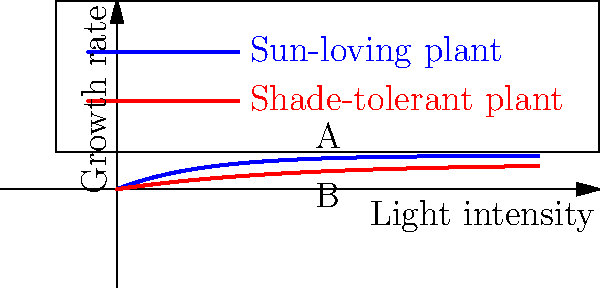Compare the growth patterns of sun-loving and shade-tolerant plants represented by curves A and B, respectively. Which mathematical property best describes the relationship between these curves? To determine the mathematical property that best describes the relationship between curves A and B, let's analyze their characteristics step-by-step:

1. Shape: Both curves have a similar overall shape, starting at the origin and increasing at a decreasing rate as light intensity increases.

2. Rate of increase: Curve A (sun-loving plant) increases more rapidly at lower light intensities compared to curve B (shade-tolerant plant).

3. Maximum growth rate: Curve A reaches a higher maximum growth rate than curve B.

4. Asymptotic behavior: Both curves appear to approach their respective maximum growth rates asymptotically as light intensity increases.

5. Transformation: The relationship between the two curves can be described as a combination of vertical stretching and horizontal compression/expansion.

6. Congruence: Despite their similarities, the curves are not identical in shape or size. They cannot be made to coincide exactly through any combination of rigid transformations (translation, rotation, or reflection).

Given these observations, the mathematical property that best describes the relationship between these curves is similarity. The curves are similar in shape but not congruent, as they differ in scale both vertically and horizontally.
Answer: Similarity 